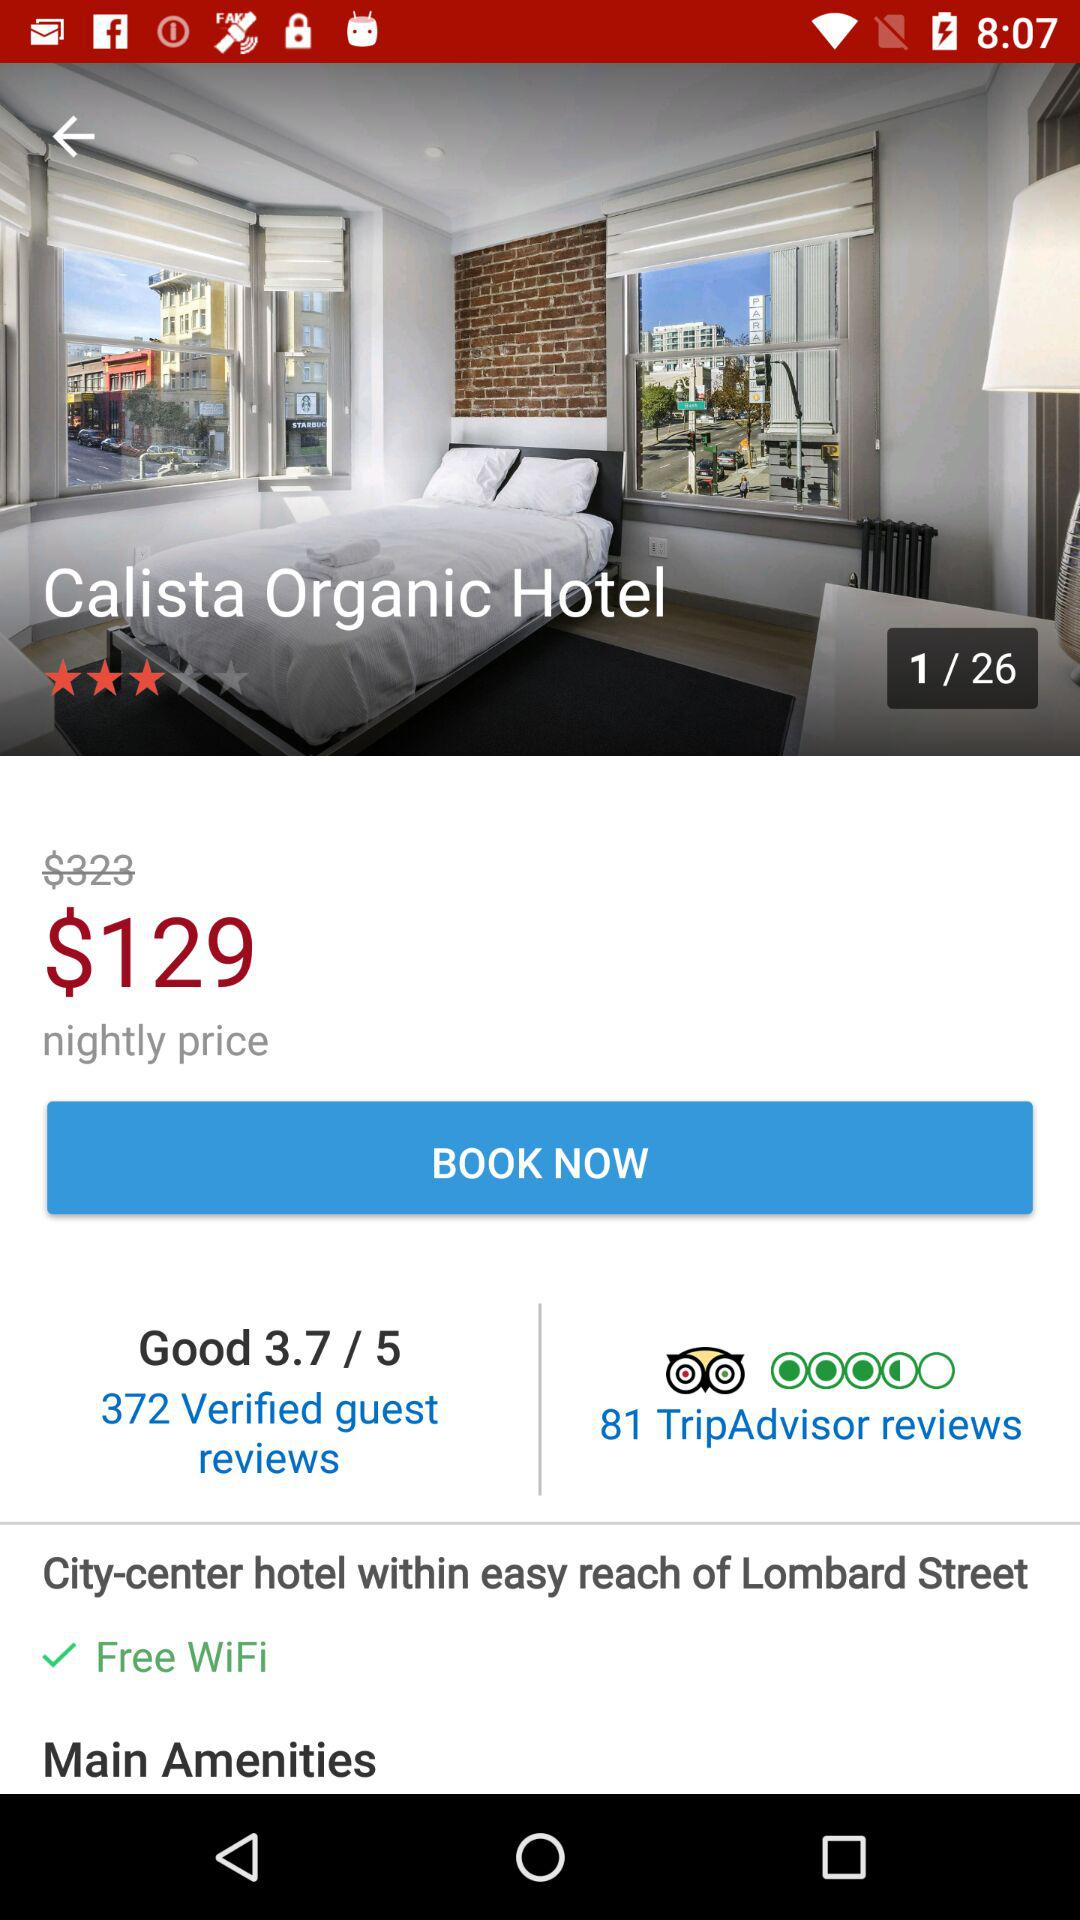What is the rating out of 5? The rating is 3.7 out of 5. 